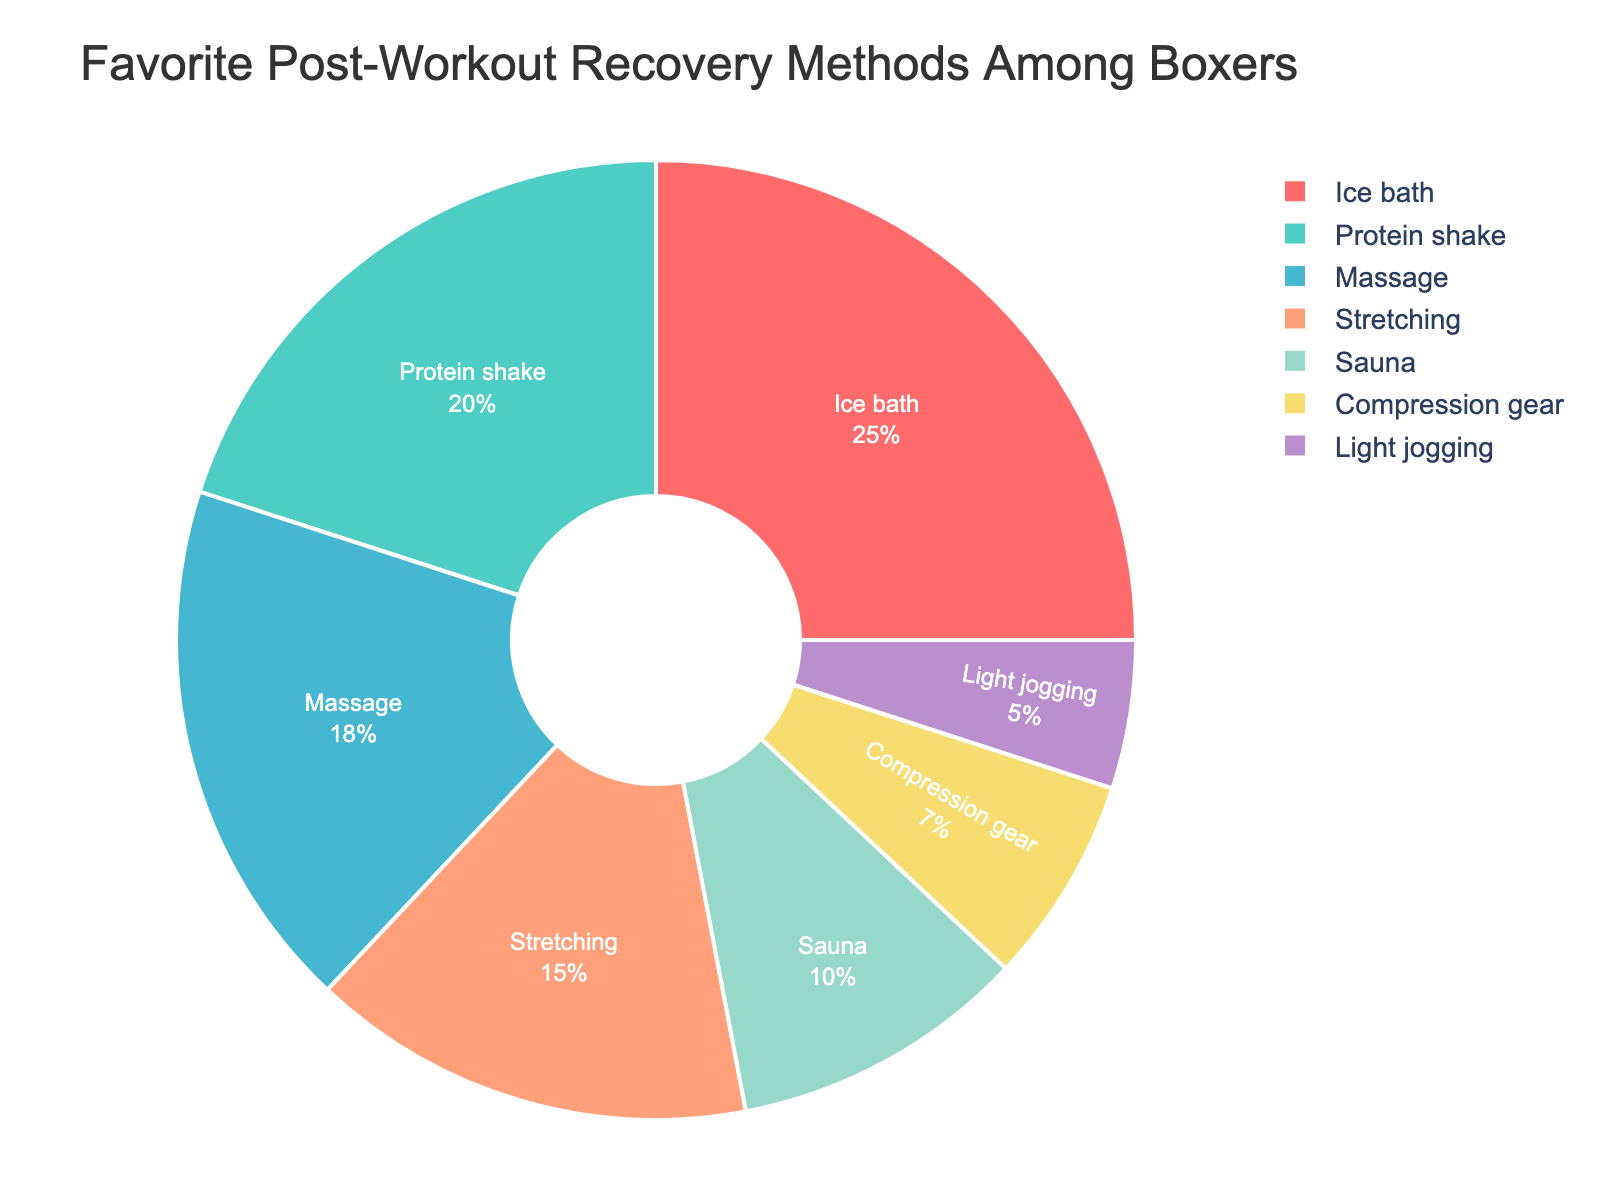What is the most popular post-workout recovery method among boxers? The largest section of the pie chart represents the most popular method, which is labeled as "Ice bath" with 25%.
Answer: Ice bath Which recovery method is the second most preferred by boxers? The second largest section of the pie chart, following "Ice bath," represents the next most popular method, labeled as "Protein shake" with 20%.
Answer: Protein shake How much more popular is the "Ice bath" compared to "Light jogging"? Subtract the percentage of "Light jogging" from the percentage of "Ice bath" (25% - 5% = 20%).
Answer: 20% What percentage of boxers prefer either "Massage" or "Stretching"? Add the percentages for "Massage" and "Stretching" (18% + 15%).
Answer: 33% Out of the total preferences shown, which recovery method has the least percentage? The smallest section of the pie chart represents "Light jogging" with 5%.
Answer: Light jogging How does the popularity of "Massage" compare to "Sauna"? Compare the percentages for "Massage" (18%) and "Sauna" (10%). Since 18% is greater than 10%, "Massage" is more popular than "Sauna".
Answer: Massage is more popular What color represents the "Protein shake" recovery method in the pie chart? The section labeled "Protein shake" is colored in a teal-like or light green color.
Answer: Teal/light green How much more popular is "Compression gear" compared to "Light jogging"? Is "Compression gear" more or less popular than "Sauna"? Calculate the difference in percentages between "Compression gear" and "Light jogging" (7% - 5% = 2%). The percentage for "Compression gear" (7%) is less than "Sauna" (10%).
Answer: "Compression gear" is 2% more popular than "Light jogging" and less popular than "Sauna" If we combine the percentages of "Sauna" and "Light jogging," how does the combined value compare to "Ice bath"? Add the percentages for "Sauna" and "Light jogging" (10% + 5% = 15%) and compare this to the percentage for "Ice bath" (25%). Since 15% is less than 25%, the combined value is less than "Ice bath".
Answer: Combined value is less Which recovery method falls in the mid-range of popularity? The section representing 15% falls in the mid-range of the pie chart, which is labeled as "Stretching."
Answer: Stretching 